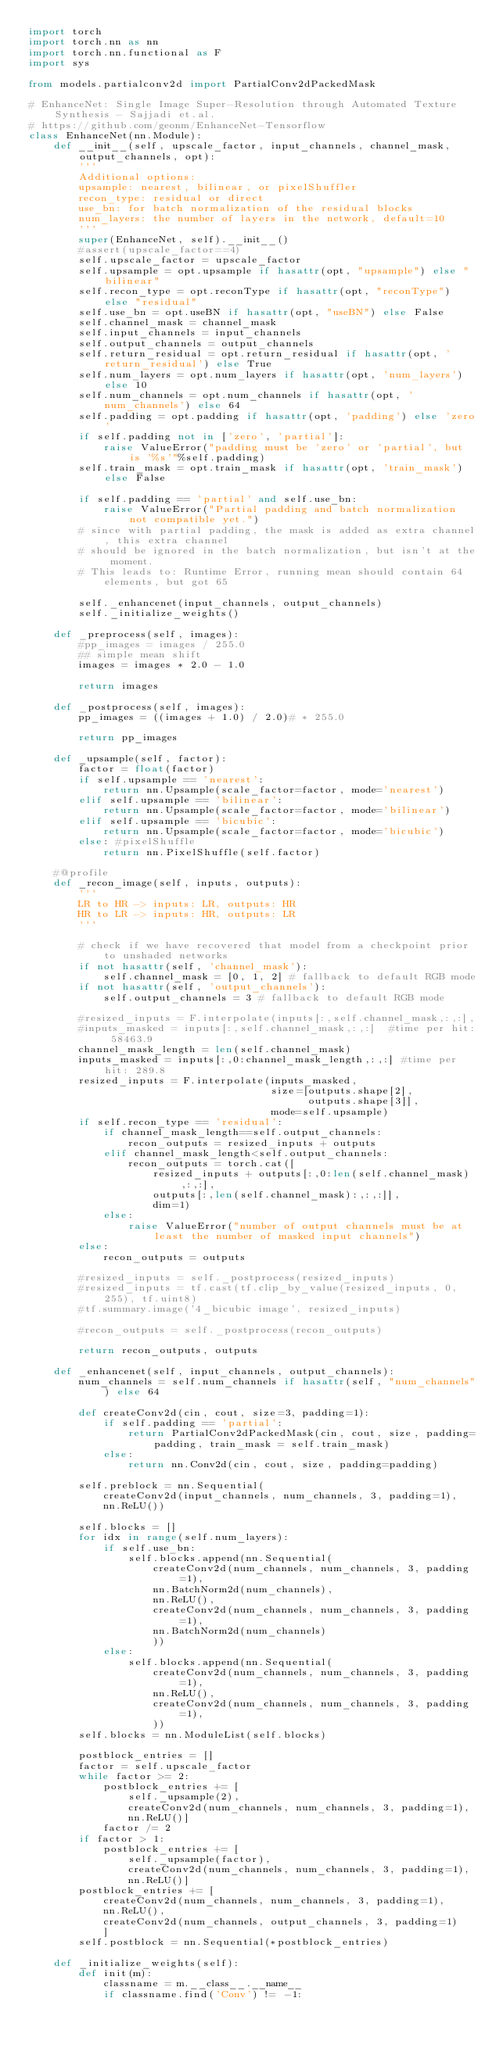Convert code to text. <code><loc_0><loc_0><loc_500><loc_500><_Python_>import torch
import torch.nn as nn
import torch.nn.functional as F
import sys

from models.partialconv2d import PartialConv2dPackedMask

# EnhanceNet: Single Image Super-Resolution through Automated Texture Synthesis - Sajjadi et.al.
# https://github.com/geonm/EnhanceNet-Tensorflow
class EnhanceNet(nn.Module):
    def __init__(self, upscale_factor, input_channels, channel_mask, output_channels, opt):
        '''
        Additional options:
        upsample: nearest, bilinear, or pixelShuffler
        recon_type: residual or direct
        use_bn: for batch normalization of the residual blocks
        num_layers: the number of layers in the network, default=10
        '''
        super(EnhanceNet, self).__init__()
        #assert(upscale_factor==4)
        self.upscale_factor = upscale_factor
        self.upsample = opt.upsample if hasattr(opt, "upsample") else "bilinear"
        self.recon_type = opt.reconType if hasattr(opt, "reconType") else "residual"
        self.use_bn = opt.useBN if hasattr(opt, "useBN") else False
        self.channel_mask = channel_mask
        self.input_channels = input_channels
        self.output_channels = output_channels
        self.return_residual = opt.return_residual if hasattr(opt, 'return_residual') else True
        self.num_layers = opt.num_layers if hasattr(opt, 'num_layers') else 10
        self.num_channels = opt.num_channels if hasattr(opt, 'num_channels') else 64
        self.padding = opt.padding if hasattr(opt, 'padding') else 'zero'
        if self.padding not in ['zero', 'partial']:
            raise ValueError("padding must be 'zero' or 'partial', but is '%s'"%self.padding)
        self.train_mask = opt.train_mask if hasattr(opt, 'train_mask') else False

        if self.padding == 'partial' and self.use_bn:
            raise ValueError("Partial padding and batch normalization not compatible yet.")
        # since with partial padding, the mask is added as extra channel, this extra channel
        # should be ignored in the batch normalization, but isn't at the moment.
        # This leads to: Runtime Error, running mean should contain 64 elements, but got 65

        self._enhancenet(input_channels, output_channels)
        self._initialize_weights()

    def _preprocess(self, images):
        #pp_images = images / 255.0
        ## simple mean shift
        images = images * 2.0 - 1.0

        return images
    
    def _postprocess(self, images):
        pp_images = ((images + 1.0) / 2.0)# * 255.0
        
        return pp_images

    def _upsample(self, factor):
        factor = float(factor)
        if self.upsample == 'nearest':
            return nn.Upsample(scale_factor=factor, mode='nearest')
        elif self.upsample == 'bilinear':
            return nn.Upsample(scale_factor=factor, mode='bilinear')
        elif self.upsample == 'bicubic':
            return nn.Upsample(scale_factor=factor, mode='bicubic')
        else: #pixelShuffle
            return nn.PixelShuffle(self.factor)

    #@profile
    def _recon_image(self, inputs, outputs):
        '''
        LR to HR -> inputs: LR, outputs: HR
        HR to LR -> inputs: HR, outputs: LR
        '''

        # check if we have recovered that model from a checkpoint prior to unshaded networks
        if not hasattr(self, 'channel_mask'):
            self.channel_mask = [0, 1, 2] # fallback to default RGB mode
        if not hasattr(self, 'output_channels'):
            self.output_channels = 3 # fallback to default RGB mode

        #resized_inputs = F.interpolate(inputs[:,self.channel_mask,:,:], 
        #inputs_masked = inputs[:,self.channel_mask,:,:]  #time per hit: 58463.9
        channel_mask_length = len(self.channel_mask)
        inputs_masked = inputs[:,0:channel_mask_length,:,:] #time per hit: 289.8
        resized_inputs = F.interpolate(inputs_masked, 
                                       size=[outputs.shape[2], 
                                             outputs.shape[3]], 
                                       mode=self.upsample)
        if self.recon_type == 'residual':
            if channel_mask_length==self.output_channels:
                recon_outputs = resized_inputs + outputs
            elif channel_mask_length<self.output_channels:
                recon_outputs = torch.cat([
                    resized_inputs + outputs[:,0:len(self.channel_mask),:,:],
                    outputs[:,len(self.channel_mask):,:,:]],
                    dim=1)
            else:
                raise ValueError("number of output channels must be at least the number of masked input channels")
        else:
            recon_outputs = outputs
        
        #resized_inputs = self._postprocess(resized_inputs)
        #resized_inputs = tf.cast(tf.clip_by_value(resized_inputs, 0, 255), tf.uint8)
        #tf.summary.image('4_bicubic image', resized_inputs)

        #recon_outputs = self._postprocess(recon_outputs)
        
        return recon_outputs, outputs
        
    def _enhancenet(self, input_channels, output_channels):
        num_channels = self.num_channels if hasattr(self, "num_channels") else 64

        def createConv2d(cin, cout, size=3, padding=1):
            if self.padding == 'partial':
                return PartialConv2dPackedMask(cin, cout, size, padding=padding, train_mask = self.train_mask)
            else:
                return nn.Conv2d(cin, cout, size, padding=padding)

        self.preblock = nn.Sequential(
            createConv2d(input_channels, num_channels, 3, padding=1),
            nn.ReLU())
            
        self.blocks = []
        for idx in range(self.num_layers):
            if self.use_bn:
                self.blocks.append(nn.Sequential(
                    createConv2d(num_channels, num_channels, 3, padding=1),
                    nn.BatchNorm2d(num_channels),
                    nn.ReLU(),
                    createConv2d(num_channels, num_channels, 3, padding=1),
                    nn.BatchNorm2d(num_channels)
                    ))
            else:
                self.blocks.append(nn.Sequential(
                    createConv2d(num_channels, num_channels, 3, padding=1),
                    nn.ReLU(),
                    createConv2d(num_channels, num_channels, 3, padding=1),
                    ))
        self.blocks = nn.ModuleList(self.blocks)
            
        postblock_entries = []
        factor = self.upscale_factor
        while factor >= 2:
            postblock_entries += [
                self._upsample(2),
                createConv2d(num_channels, num_channels, 3, padding=1),
                nn.ReLU()]
            factor /= 2
        if factor > 1:
            postblock_entries += [
                self._upsample(factor),
                createConv2d(num_channels, num_channels, 3, padding=1),
                nn.ReLU()]
        postblock_entries += [
            createConv2d(num_channels, num_channels, 3, padding=1),
            nn.ReLU(),
            createConv2d(num_channels, output_channels, 3, padding=1)
            ]
        self.postblock = nn.Sequential(*postblock_entries)

    def _initialize_weights(self):
        def init(m):
            classname = m.__class__.__name__
            if classname.find('Conv') != -1:</code> 